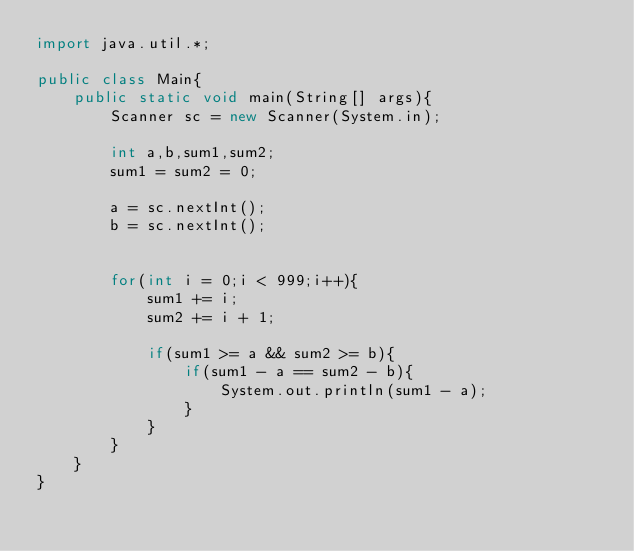Convert code to text. <code><loc_0><loc_0><loc_500><loc_500><_Java_>import java.util.*;

public class Main{
	public static void main(String[] args){
		Scanner sc = new Scanner(System.in);
		
		int a,b,sum1,sum2;
		sum1 = sum2 = 0;
		
		a = sc.nextInt();
		b = sc.nextInt();
		
		
		for(int i = 0;i < 999;i++){
			sum1 += i;
			sum2 += i + 1;
			
			if(sum1 >= a && sum2 >= b){
				if(sum1 - a == sum2 - b){
					System.out.println(sum1 - a);
				}
			}
		}
	}
}</code> 